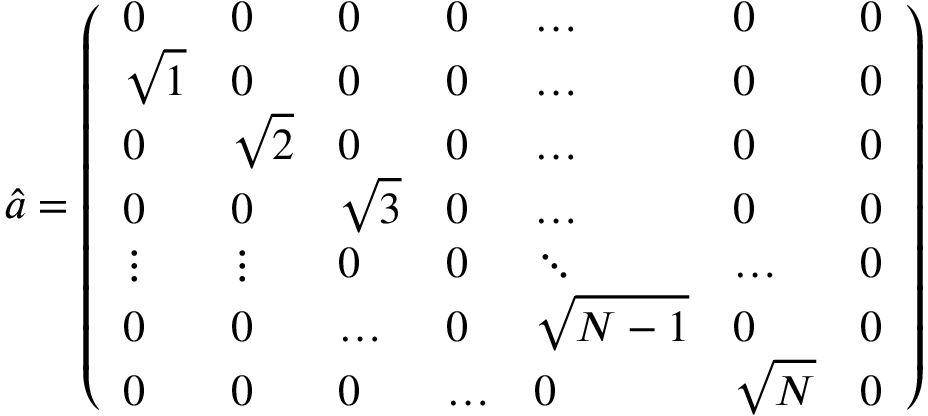Convert formula to latex. <formula><loc_0><loc_0><loc_500><loc_500>\hat { a } = \left ( \begin{array} { l l l l l l l } { 0 } & { 0 } & { 0 } & { 0 } & { \dots } & { 0 } & { 0 } \\ { \sqrt { 1 } } & { 0 } & { 0 } & { 0 } & { \dots } & { 0 } & { 0 } \\ { 0 } & { \sqrt { 2 } } & { 0 } & { 0 } & { \dots } & { 0 } & { 0 } \\ { 0 } & { 0 } & { \sqrt { 3 } } & { 0 } & { \dots } & { 0 } & { 0 } \\ { \vdots } & { \vdots } & { 0 } & { 0 } & { \ddots } & { \dots } & { 0 } \\ { 0 } & { 0 } & { \dots } & { 0 } & { \sqrt { N - 1 } } & { 0 } & { 0 } \\ { 0 } & { 0 } & { 0 } & { \dots } & { 0 } & { \sqrt { N } } & { 0 } \end{array} \right )</formula> 